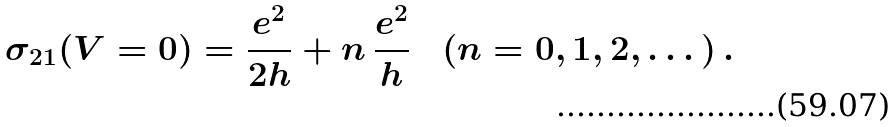<formula> <loc_0><loc_0><loc_500><loc_500>\sigma _ { 2 1 } ( V = 0 ) = \frac { e ^ { 2 } } { 2 h } + n \, \frac { e ^ { 2 } } { h } \quad ( n = 0 , 1 , 2 , \dots ) \, .</formula> 